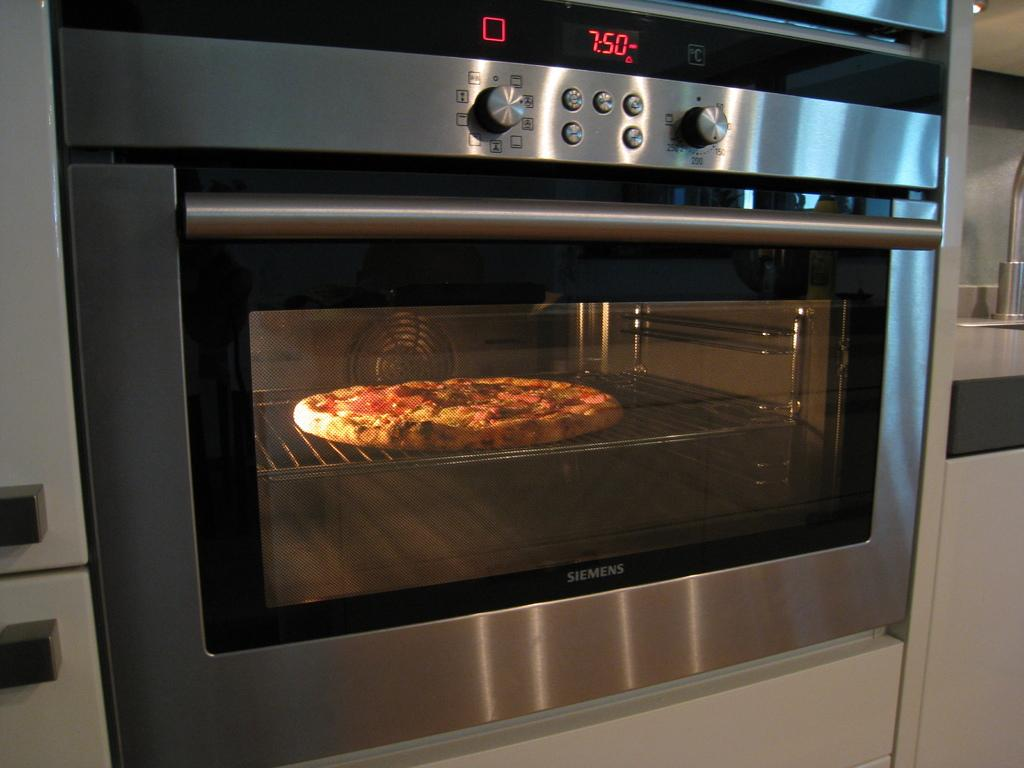<image>
Give a short and clear explanation of the subsequent image. an oven on that shows the time as 7:50 